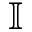Convert formula to latex. <formula><loc_0><loc_0><loc_500><loc_500>\mathbb { I }</formula> 